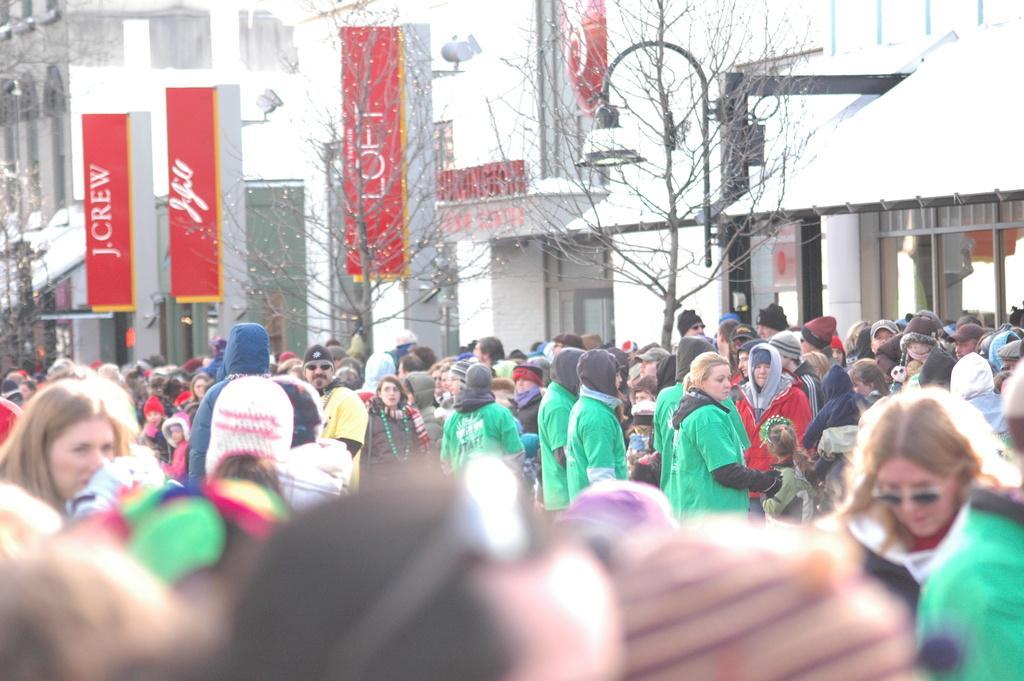Please provide a concise description of this image. In this picture I can see a group of people in the middle, in the background there are trees, boards, lights and buildings. 